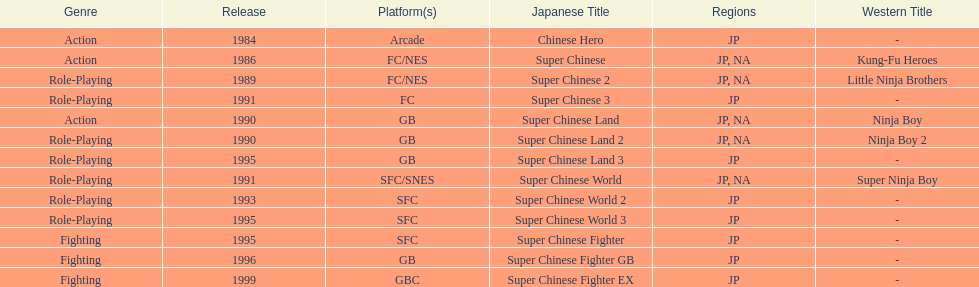Number of super chinese world games released 3. 